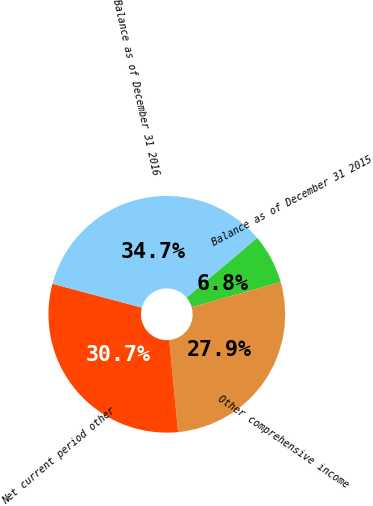Convert chart to OTSL. <chart><loc_0><loc_0><loc_500><loc_500><pie_chart><fcel>Balance as of December 31 2015<fcel>Other comprehensive income<fcel>Net current period other<fcel>Balance as of December 31 2016<nl><fcel>6.78%<fcel>27.88%<fcel>30.67%<fcel>34.66%<nl></chart> 